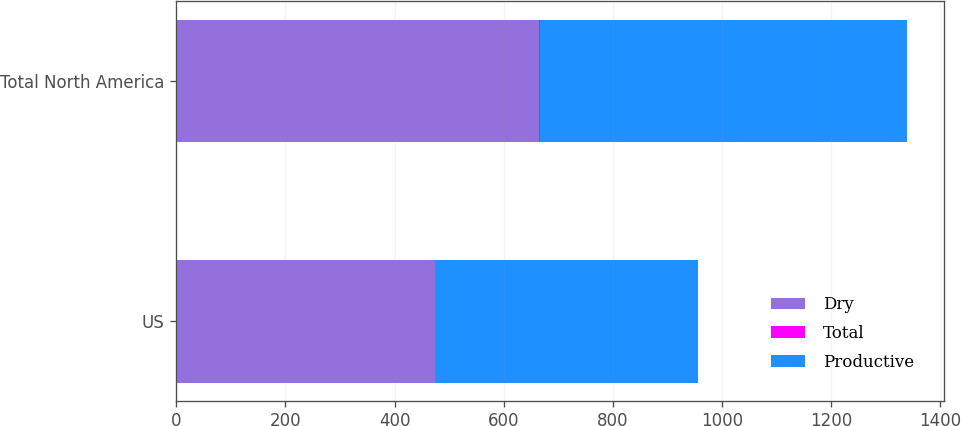Convert chart. <chart><loc_0><loc_0><loc_500><loc_500><stacked_bar_chart><ecel><fcel>US<fcel>Total North America<nl><fcel>Dry<fcel>474.4<fcel>665.2<nl><fcel>Total<fcel>0.4<fcel>1.4<nl><fcel>Productive<fcel>481<fcel>673.3<nl></chart> 